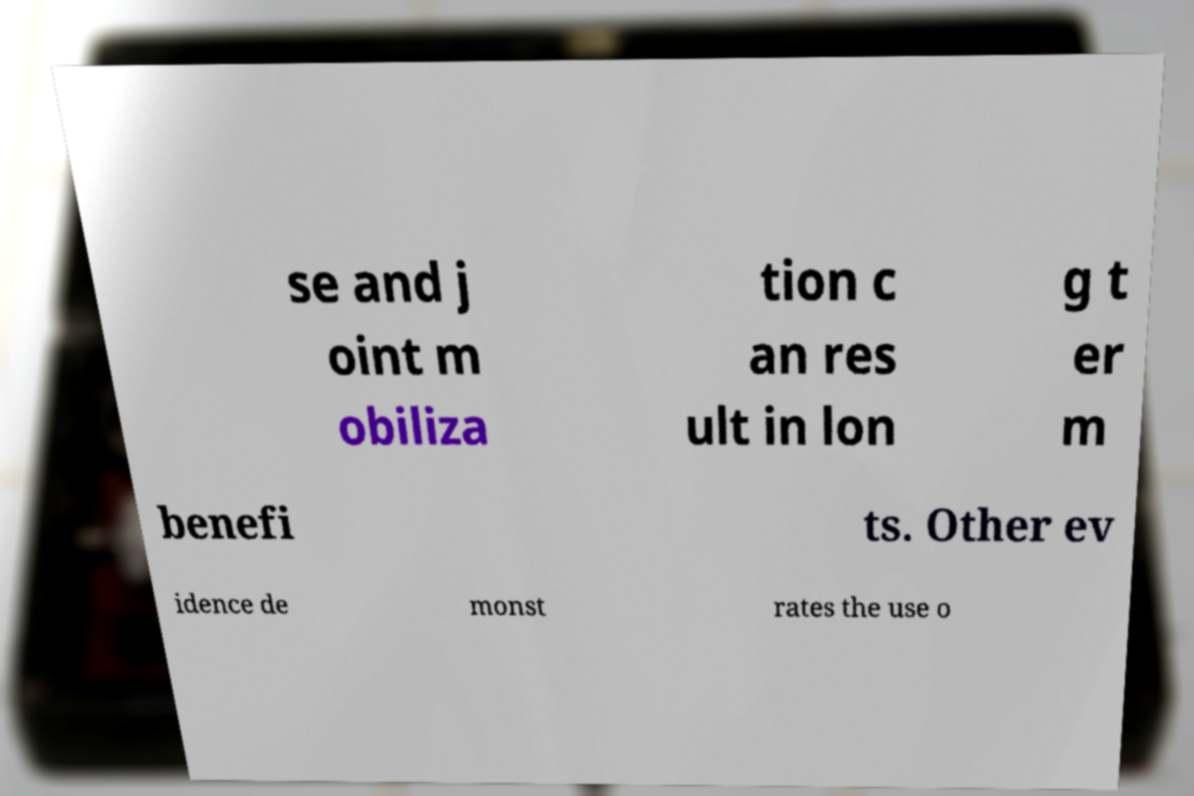Could you assist in decoding the text presented in this image and type it out clearly? se and j oint m obiliza tion c an res ult in lon g t er m benefi ts. Other ev idence de monst rates the use o 